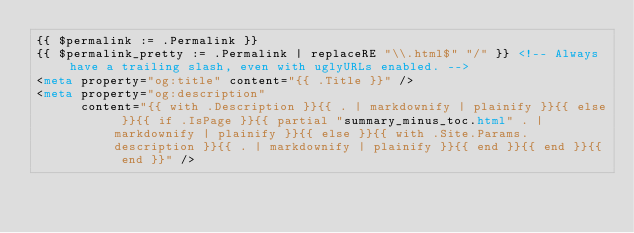Convert code to text. <code><loc_0><loc_0><loc_500><loc_500><_HTML_>{{ $permalink := .Permalink }}
{{ $permalink_pretty := .Permalink | replaceRE "\\.html$" "/" }} <!-- Always have a trailing slash, even with uglyURLs enabled. -->
<meta property="og:title" content="{{ .Title }}" />
<meta property="og:description"
      content="{{ with .Description }}{{ . | markdownify | plainify }}{{ else }}{{ if .IsPage }}{{ partial "summary_minus_toc.html" . | markdownify | plainify }}{{ else }}{{ with .Site.Params.description }}{{ . | markdownify | plainify }}{{ end }}{{ end }}{{ end }}" /></code> 